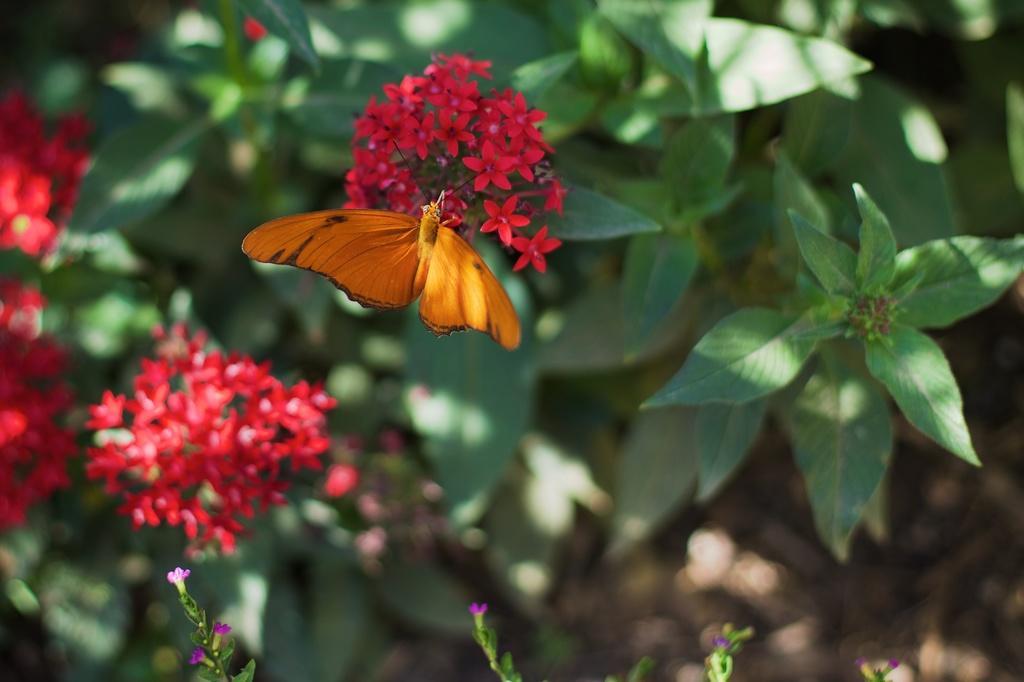Can you describe this image briefly? In this image we can see an insect such as a butterfly on the flowers. And we can see the leaves and plants. 